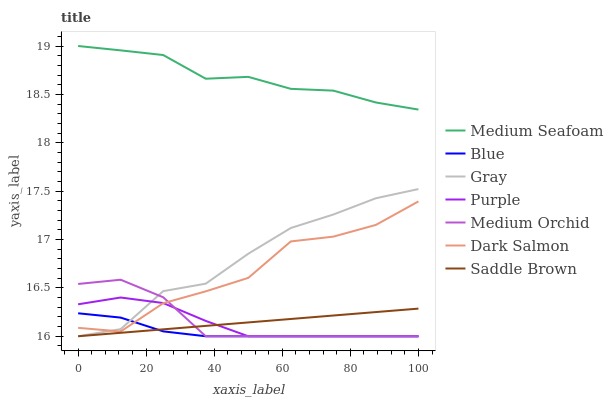Does Gray have the minimum area under the curve?
Answer yes or no. No. Does Gray have the maximum area under the curve?
Answer yes or no. No. Is Gray the smoothest?
Answer yes or no. No. Is Gray the roughest?
Answer yes or no. No. Does Dark Salmon have the lowest value?
Answer yes or no. No. Does Gray have the highest value?
Answer yes or no. No. Is Purple less than Medium Seafoam?
Answer yes or no. Yes. Is Medium Seafoam greater than Purple?
Answer yes or no. Yes. Does Purple intersect Medium Seafoam?
Answer yes or no. No. 